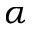<formula> <loc_0><loc_0><loc_500><loc_500>\alpha</formula> 